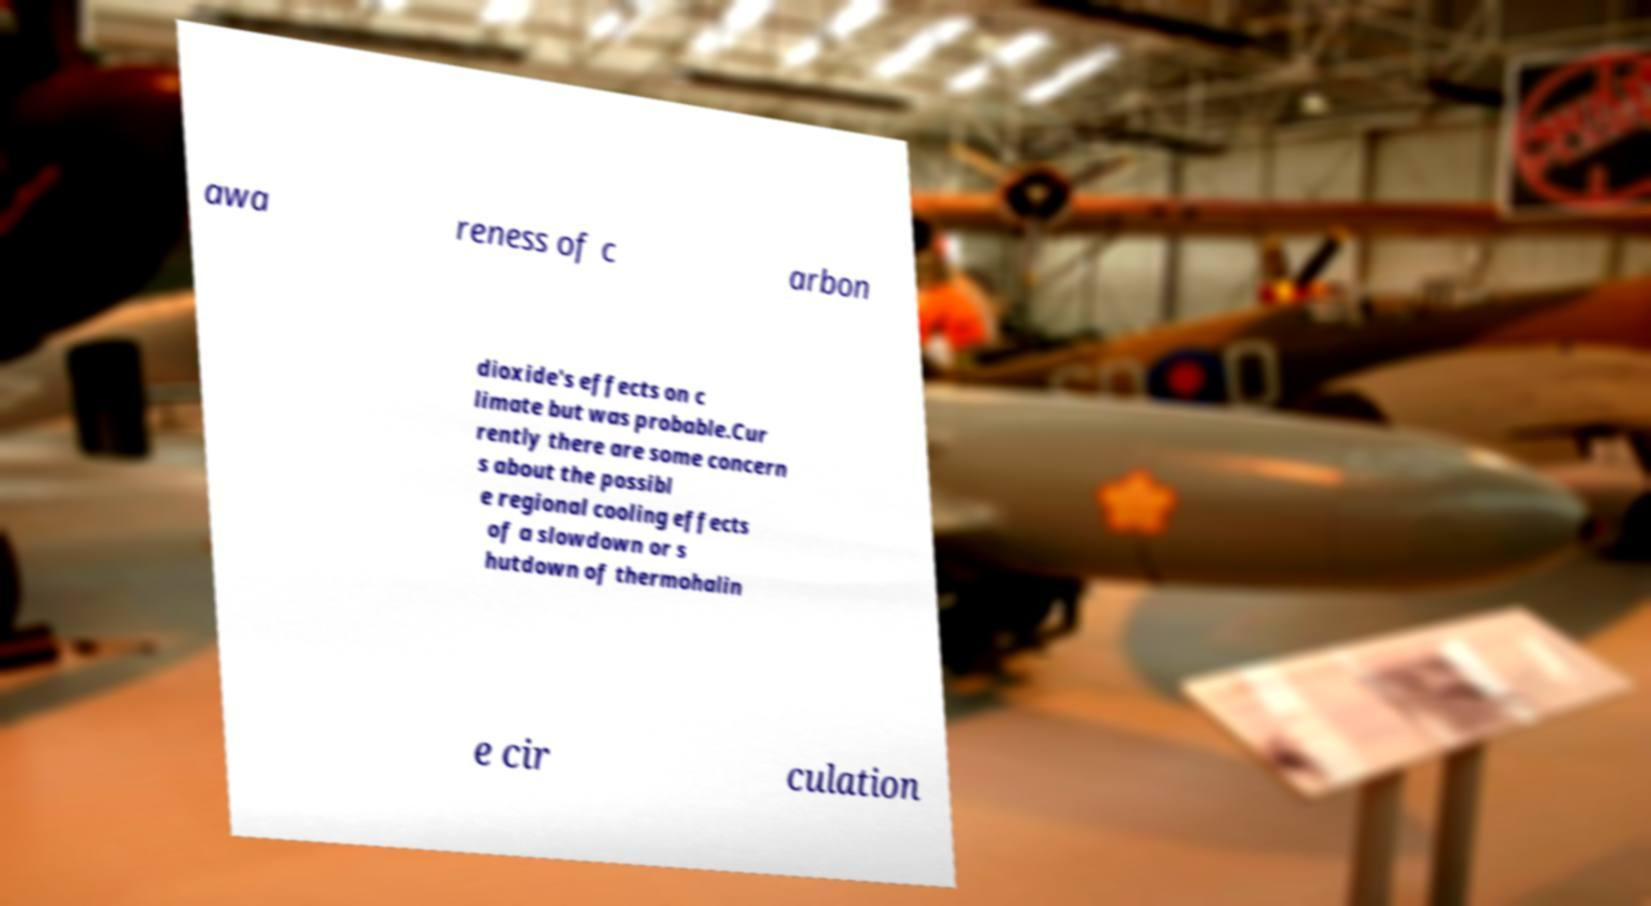What messages or text are displayed in this image? I need them in a readable, typed format. awa reness of c arbon dioxide's effects on c limate but was probable.Cur rently there are some concern s about the possibl e regional cooling effects of a slowdown or s hutdown of thermohalin e cir culation 